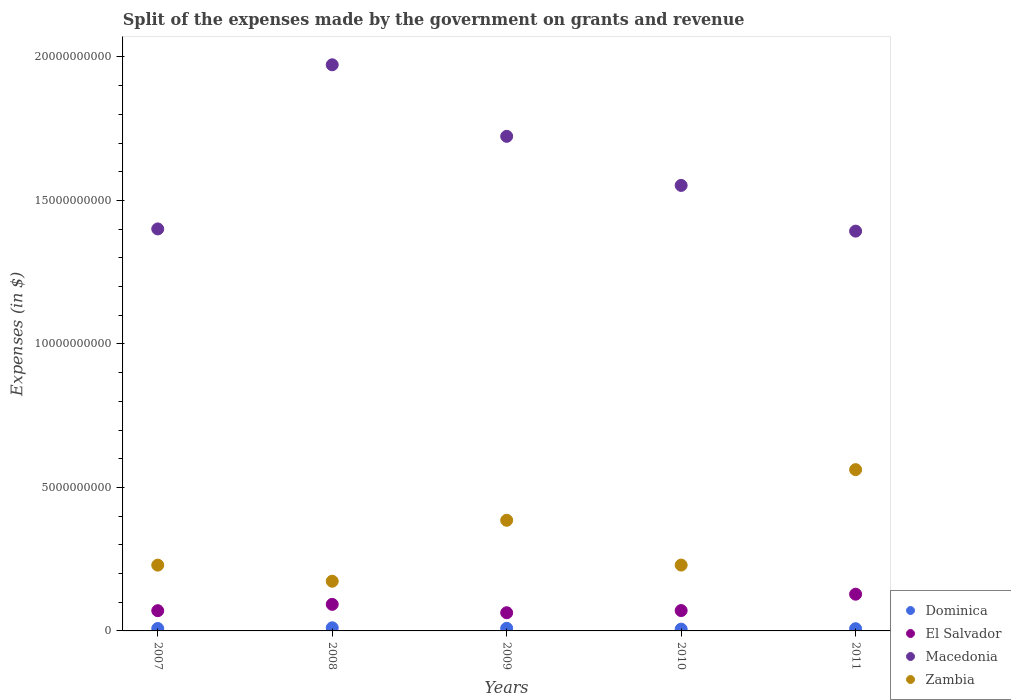Is the number of dotlines equal to the number of legend labels?
Your answer should be compact. Yes. What is the expenses made by the government on grants and revenue in Zambia in 2009?
Offer a very short reply. 3.86e+09. Across all years, what is the maximum expenses made by the government on grants and revenue in Zambia?
Offer a very short reply. 5.62e+09. Across all years, what is the minimum expenses made by the government on grants and revenue in El Salvador?
Keep it short and to the point. 6.34e+08. What is the total expenses made by the government on grants and revenue in Zambia in the graph?
Your answer should be compact. 1.58e+1. What is the difference between the expenses made by the government on grants and revenue in Macedonia in 2007 and that in 2008?
Make the answer very short. -5.72e+09. What is the difference between the expenses made by the government on grants and revenue in Zambia in 2011 and the expenses made by the government on grants and revenue in Macedonia in 2009?
Provide a succinct answer. -1.16e+1. What is the average expenses made by the government on grants and revenue in Dominica per year?
Offer a very short reply. 8.47e+07. In the year 2008, what is the difference between the expenses made by the government on grants and revenue in Dominica and expenses made by the government on grants and revenue in El Salvador?
Provide a succinct answer. -8.17e+08. What is the ratio of the expenses made by the government on grants and revenue in Dominica in 2008 to that in 2010?
Keep it short and to the point. 1.73. Is the expenses made by the government on grants and revenue in Macedonia in 2009 less than that in 2010?
Give a very brief answer. No. Is the difference between the expenses made by the government on grants and revenue in Dominica in 2008 and 2010 greater than the difference between the expenses made by the government on grants and revenue in El Salvador in 2008 and 2010?
Offer a very short reply. No. What is the difference between the highest and the second highest expenses made by the government on grants and revenue in El Salvador?
Your response must be concise. 3.54e+08. What is the difference between the highest and the lowest expenses made by the government on grants and revenue in Dominica?
Give a very brief answer. 4.58e+07. Is it the case that in every year, the sum of the expenses made by the government on grants and revenue in Zambia and expenses made by the government on grants and revenue in Dominica  is greater than the sum of expenses made by the government on grants and revenue in El Salvador and expenses made by the government on grants and revenue in Macedonia?
Your answer should be compact. Yes. Does the expenses made by the government on grants and revenue in Zambia monotonically increase over the years?
Your answer should be very brief. No. Is the expenses made by the government on grants and revenue in Macedonia strictly greater than the expenses made by the government on grants and revenue in Zambia over the years?
Provide a succinct answer. Yes. How many years are there in the graph?
Offer a terse response. 5. Are the values on the major ticks of Y-axis written in scientific E-notation?
Offer a terse response. No. Where does the legend appear in the graph?
Make the answer very short. Bottom right. How many legend labels are there?
Provide a succinct answer. 4. How are the legend labels stacked?
Offer a very short reply. Vertical. What is the title of the graph?
Ensure brevity in your answer.  Split of the expenses made by the government on grants and revenue. What is the label or title of the Y-axis?
Your answer should be very brief. Expenses (in $). What is the Expenses (in $) in Dominica in 2007?
Offer a very short reply. 8.40e+07. What is the Expenses (in $) of El Salvador in 2007?
Offer a terse response. 7.05e+08. What is the Expenses (in $) of Macedonia in 2007?
Ensure brevity in your answer.  1.40e+1. What is the Expenses (in $) of Zambia in 2007?
Your response must be concise. 2.29e+09. What is the Expenses (in $) of Dominica in 2008?
Ensure brevity in your answer.  1.09e+08. What is the Expenses (in $) in El Salvador in 2008?
Your answer should be very brief. 9.26e+08. What is the Expenses (in $) in Macedonia in 2008?
Offer a terse response. 1.97e+1. What is the Expenses (in $) in Zambia in 2008?
Offer a very short reply. 1.73e+09. What is the Expenses (in $) of Dominica in 2009?
Your answer should be very brief. 9.12e+07. What is the Expenses (in $) of El Salvador in 2009?
Ensure brevity in your answer.  6.34e+08. What is the Expenses (in $) in Macedonia in 2009?
Ensure brevity in your answer.  1.72e+1. What is the Expenses (in $) of Zambia in 2009?
Offer a terse response. 3.86e+09. What is the Expenses (in $) in Dominica in 2010?
Give a very brief answer. 6.28e+07. What is the Expenses (in $) of El Salvador in 2010?
Your response must be concise. 7.09e+08. What is the Expenses (in $) of Macedonia in 2010?
Your response must be concise. 1.55e+1. What is the Expenses (in $) in Zambia in 2010?
Keep it short and to the point. 2.29e+09. What is the Expenses (in $) of Dominica in 2011?
Give a very brief answer. 7.71e+07. What is the Expenses (in $) of El Salvador in 2011?
Your response must be concise. 1.28e+09. What is the Expenses (in $) in Macedonia in 2011?
Your answer should be very brief. 1.39e+1. What is the Expenses (in $) of Zambia in 2011?
Ensure brevity in your answer.  5.62e+09. Across all years, what is the maximum Expenses (in $) in Dominica?
Offer a terse response. 1.09e+08. Across all years, what is the maximum Expenses (in $) in El Salvador?
Make the answer very short. 1.28e+09. Across all years, what is the maximum Expenses (in $) of Macedonia?
Give a very brief answer. 1.97e+1. Across all years, what is the maximum Expenses (in $) of Zambia?
Your answer should be compact. 5.62e+09. Across all years, what is the minimum Expenses (in $) of Dominica?
Your response must be concise. 6.28e+07. Across all years, what is the minimum Expenses (in $) of El Salvador?
Provide a succinct answer. 6.34e+08. Across all years, what is the minimum Expenses (in $) of Macedonia?
Your response must be concise. 1.39e+1. Across all years, what is the minimum Expenses (in $) in Zambia?
Your answer should be compact. 1.73e+09. What is the total Expenses (in $) in Dominica in the graph?
Your answer should be very brief. 4.24e+08. What is the total Expenses (in $) of El Salvador in the graph?
Offer a very short reply. 4.25e+09. What is the total Expenses (in $) in Macedonia in the graph?
Your response must be concise. 8.04e+1. What is the total Expenses (in $) of Zambia in the graph?
Give a very brief answer. 1.58e+1. What is the difference between the Expenses (in $) in Dominica in 2007 and that in 2008?
Your response must be concise. -2.46e+07. What is the difference between the Expenses (in $) of El Salvador in 2007 and that in 2008?
Provide a short and direct response. -2.20e+08. What is the difference between the Expenses (in $) of Macedonia in 2007 and that in 2008?
Provide a succinct answer. -5.72e+09. What is the difference between the Expenses (in $) in Zambia in 2007 and that in 2008?
Your answer should be very brief. 5.61e+08. What is the difference between the Expenses (in $) of Dominica in 2007 and that in 2009?
Ensure brevity in your answer.  -7.20e+06. What is the difference between the Expenses (in $) in El Salvador in 2007 and that in 2009?
Keep it short and to the point. 7.15e+07. What is the difference between the Expenses (in $) of Macedonia in 2007 and that in 2009?
Offer a very short reply. -3.23e+09. What is the difference between the Expenses (in $) of Zambia in 2007 and that in 2009?
Your answer should be very brief. -1.56e+09. What is the difference between the Expenses (in $) of Dominica in 2007 and that in 2010?
Keep it short and to the point. 2.12e+07. What is the difference between the Expenses (in $) of El Salvador in 2007 and that in 2010?
Provide a short and direct response. -4.20e+06. What is the difference between the Expenses (in $) of Macedonia in 2007 and that in 2010?
Offer a very short reply. -1.52e+09. What is the difference between the Expenses (in $) in Zambia in 2007 and that in 2010?
Your response must be concise. -1.88e+06. What is the difference between the Expenses (in $) in Dominica in 2007 and that in 2011?
Keep it short and to the point. 6.90e+06. What is the difference between the Expenses (in $) in El Salvador in 2007 and that in 2011?
Ensure brevity in your answer.  -5.74e+08. What is the difference between the Expenses (in $) of Macedonia in 2007 and that in 2011?
Make the answer very short. 7.66e+07. What is the difference between the Expenses (in $) of Zambia in 2007 and that in 2011?
Provide a short and direct response. -3.33e+09. What is the difference between the Expenses (in $) of Dominica in 2008 and that in 2009?
Your response must be concise. 1.74e+07. What is the difference between the Expenses (in $) in El Salvador in 2008 and that in 2009?
Keep it short and to the point. 2.92e+08. What is the difference between the Expenses (in $) in Macedonia in 2008 and that in 2009?
Give a very brief answer. 2.49e+09. What is the difference between the Expenses (in $) in Zambia in 2008 and that in 2009?
Ensure brevity in your answer.  -2.12e+09. What is the difference between the Expenses (in $) in Dominica in 2008 and that in 2010?
Offer a terse response. 4.58e+07. What is the difference between the Expenses (in $) in El Salvador in 2008 and that in 2010?
Your answer should be very brief. 2.16e+08. What is the difference between the Expenses (in $) in Macedonia in 2008 and that in 2010?
Provide a short and direct response. 4.20e+09. What is the difference between the Expenses (in $) in Zambia in 2008 and that in 2010?
Offer a terse response. -5.63e+08. What is the difference between the Expenses (in $) of Dominica in 2008 and that in 2011?
Keep it short and to the point. 3.15e+07. What is the difference between the Expenses (in $) in El Salvador in 2008 and that in 2011?
Your answer should be very brief. -3.54e+08. What is the difference between the Expenses (in $) in Macedonia in 2008 and that in 2011?
Provide a succinct answer. 5.80e+09. What is the difference between the Expenses (in $) in Zambia in 2008 and that in 2011?
Provide a succinct answer. -3.89e+09. What is the difference between the Expenses (in $) in Dominica in 2009 and that in 2010?
Provide a succinct answer. 2.84e+07. What is the difference between the Expenses (in $) in El Salvador in 2009 and that in 2010?
Make the answer very short. -7.57e+07. What is the difference between the Expenses (in $) of Macedonia in 2009 and that in 2010?
Provide a short and direct response. 1.71e+09. What is the difference between the Expenses (in $) of Zambia in 2009 and that in 2010?
Offer a terse response. 1.56e+09. What is the difference between the Expenses (in $) of Dominica in 2009 and that in 2011?
Keep it short and to the point. 1.41e+07. What is the difference between the Expenses (in $) of El Salvador in 2009 and that in 2011?
Offer a very short reply. -6.46e+08. What is the difference between the Expenses (in $) of Macedonia in 2009 and that in 2011?
Make the answer very short. 3.30e+09. What is the difference between the Expenses (in $) in Zambia in 2009 and that in 2011?
Make the answer very short. -1.76e+09. What is the difference between the Expenses (in $) of Dominica in 2010 and that in 2011?
Your answer should be very brief. -1.43e+07. What is the difference between the Expenses (in $) in El Salvador in 2010 and that in 2011?
Your answer should be very brief. -5.70e+08. What is the difference between the Expenses (in $) in Macedonia in 2010 and that in 2011?
Offer a terse response. 1.59e+09. What is the difference between the Expenses (in $) of Zambia in 2010 and that in 2011?
Make the answer very short. -3.33e+09. What is the difference between the Expenses (in $) of Dominica in 2007 and the Expenses (in $) of El Salvador in 2008?
Provide a succinct answer. -8.42e+08. What is the difference between the Expenses (in $) of Dominica in 2007 and the Expenses (in $) of Macedonia in 2008?
Offer a terse response. -1.96e+1. What is the difference between the Expenses (in $) of Dominica in 2007 and the Expenses (in $) of Zambia in 2008?
Your answer should be very brief. -1.65e+09. What is the difference between the Expenses (in $) of El Salvador in 2007 and the Expenses (in $) of Macedonia in 2008?
Provide a short and direct response. -1.90e+1. What is the difference between the Expenses (in $) in El Salvador in 2007 and the Expenses (in $) in Zambia in 2008?
Your response must be concise. -1.03e+09. What is the difference between the Expenses (in $) of Macedonia in 2007 and the Expenses (in $) of Zambia in 2008?
Ensure brevity in your answer.  1.23e+1. What is the difference between the Expenses (in $) of Dominica in 2007 and the Expenses (in $) of El Salvador in 2009?
Provide a succinct answer. -5.50e+08. What is the difference between the Expenses (in $) of Dominica in 2007 and the Expenses (in $) of Macedonia in 2009?
Your response must be concise. -1.72e+1. What is the difference between the Expenses (in $) in Dominica in 2007 and the Expenses (in $) in Zambia in 2009?
Ensure brevity in your answer.  -3.77e+09. What is the difference between the Expenses (in $) of El Salvador in 2007 and the Expenses (in $) of Macedonia in 2009?
Make the answer very short. -1.65e+1. What is the difference between the Expenses (in $) in El Salvador in 2007 and the Expenses (in $) in Zambia in 2009?
Make the answer very short. -3.15e+09. What is the difference between the Expenses (in $) in Macedonia in 2007 and the Expenses (in $) in Zambia in 2009?
Offer a very short reply. 1.02e+1. What is the difference between the Expenses (in $) in Dominica in 2007 and the Expenses (in $) in El Salvador in 2010?
Your response must be concise. -6.25e+08. What is the difference between the Expenses (in $) of Dominica in 2007 and the Expenses (in $) of Macedonia in 2010?
Give a very brief answer. -1.54e+1. What is the difference between the Expenses (in $) in Dominica in 2007 and the Expenses (in $) in Zambia in 2010?
Your response must be concise. -2.21e+09. What is the difference between the Expenses (in $) of El Salvador in 2007 and the Expenses (in $) of Macedonia in 2010?
Ensure brevity in your answer.  -1.48e+1. What is the difference between the Expenses (in $) in El Salvador in 2007 and the Expenses (in $) in Zambia in 2010?
Provide a short and direct response. -1.59e+09. What is the difference between the Expenses (in $) of Macedonia in 2007 and the Expenses (in $) of Zambia in 2010?
Provide a succinct answer. 1.17e+1. What is the difference between the Expenses (in $) of Dominica in 2007 and the Expenses (in $) of El Salvador in 2011?
Give a very brief answer. -1.20e+09. What is the difference between the Expenses (in $) in Dominica in 2007 and the Expenses (in $) in Macedonia in 2011?
Make the answer very short. -1.38e+1. What is the difference between the Expenses (in $) of Dominica in 2007 and the Expenses (in $) of Zambia in 2011?
Your response must be concise. -5.54e+09. What is the difference between the Expenses (in $) in El Salvador in 2007 and the Expenses (in $) in Macedonia in 2011?
Keep it short and to the point. -1.32e+1. What is the difference between the Expenses (in $) of El Salvador in 2007 and the Expenses (in $) of Zambia in 2011?
Your answer should be very brief. -4.91e+09. What is the difference between the Expenses (in $) in Macedonia in 2007 and the Expenses (in $) in Zambia in 2011?
Make the answer very short. 8.39e+09. What is the difference between the Expenses (in $) of Dominica in 2008 and the Expenses (in $) of El Salvador in 2009?
Provide a succinct answer. -5.25e+08. What is the difference between the Expenses (in $) of Dominica in 2008 and the Expenses (in $) of Macedonia in 2009?
Keep it short and to the point. -1.71e+1. What is the difference between the Expenses (in $) of Dominica in 2008 and the Expenses (in $) of Zambia in 2009?
Your answer should be very brief. -3.75e+09. What is the difference between the Expenses (in $) of El Salvador in 2008 and the Expenses (in $) of Macedonia in 2009?
Ensure brevity in your answer.  -1.63e+1. What is the difference between the Expenses (in $) of El Salvador in 2008 and the Expenses (in $) of Zambia in 2009?
Your response must be concise. -2.93e+09. What is the difference between the Expenses (in $) of Macedonia in 2008 and the Expenses (in $) of Zambia in 2009?
Offer a very short reply. 1.59e+1. What is the difference between the Expenses (in $) in Dominica in 2008 and the Expenses (in $) in El Salvador in 2010?
Make the answer very short. -6.01e+08. What is the difference between the Expenses (in $) of Dominica in 2008 and the Expenses (in $) of Macedonia in 2010?
Provide a short and direct response. -1.54e+1. What is the difference between the Expenses (in $) of Dominica in 2008 and the Expenses (in $) of Zambia in 2010?
Ensure brevity in your answer.  -2.19e+09. What is the difference between the Expenses (in $) of El Salvador in 2008 and the Expenses (in $) of Macedonia in 2010?
Offer a very short reply. -1.46e+1. What is the difference between the Expenses (in $) of El Salvador in 2008 and the Expenses (in $) of Zambia in 2010?
Your response must be concise. -1.37e+09. What is the difference between the Expenses (in $) in Macedonia in 2008 and the Expenses (in $) in Zambia in 2010?
Make the answer very short. 1.74e+1. What is the difference between the Expenses (in $) of Dominica in 2008 and the Expenses (in $) of El Salvador in 2011?
Offer a terse response. -1.17e+09. What is the difference between the Expenses (in $) in Dominica in 2008 and the Expenses (in $) in Macedonia in 2011?
Give a very brief answer. -1.38e+1. What is the difference between the Expenses (in $) of Dominica in 2008 and the Expenses (in $) of Zambia in 2011?
Ensure brevity in your answer.  -5.51e+09. What is the difference between the Expenses (in $) of El Salvador in 2008 and the Expenses (in $) of Macedonia in 2011?
Give a very brief answer. -1.30e+1. What is the difference between the Expenses (in $) in El Salvador in 2008 and the Expenses (in $) in Zambia in 2011?
Provide a succinct answer. -4.69e+09. What is the difference between the Expenses (in $) of Macedonia in 2008 and the Expenses (in $) of Zambia in 2011?
Your response must be concise. 1.41e+1. What is the difference between the Expenses (in $) of Dominica in 2009 and the Expenses (in $) of El Salvador in 2010?
Provide a succinct answer. -6.18e+08. What is the difference between the Expenses (in $) in Dominica in 2009 and the Expenses (in $) in Macedonia in 2010?
Your answer should be compact. -1.54e+1. What is the difference between the Expenses (in $) in Dominica in 2009 and the Expenses (in $) in Zambia in 2010?
Ensure brevity in your answer.  -2.20e+09. What is the difference between the Expenses (in $) in El Salvador in 2009 and the Expenses (in $) in Macedonia in 2010?
Give a very brief answer. -1.49e+1. What is the difference between the Expenses (in $) in El Salvador in 2009 and the Expenses (in $) in Zambia in 2010?
Offer a terse response. -1.66e+09. What is the difference between the Expenses (in $) in Macedonia in 2009 and the Expenses (in $) in Zambia in 2010?
Make the answer very short. 1.49e+1. What is the difference between the Expenses (in $) in Dominica in 2009 and the Expenses (in $) in El Salvador in 2011?
Provide a succinct answer. -1.19e+09. What is the difference between the Expenses (in $) of Dominica in 2009 and the Expenses (in $) of Macedonia in 2011?
Your answer should be very brief. -1.38e+1. What is the difference between the Expenses (in $) of Dominica in 2009 and the Expenses (in $) of Zambia in 2011?
Your answer should be very brief. -5.53e+09. What is the difference between the Expenses (in $) in El Salvador in 2009 and the Expenses (in $) in Macedonia in 2011?
Offer a terse response. -1.33e+1. What is the difference between the Expenses (in $) in El Salvador in 2009 and the Expenses (in $) in Zambia in 2011?
Offer a very short reply. -4.99e+09. What is the difference between the Expenses (in $) in Macedonia in 2009 and the Expenses (in $) in Zambia in 2011?
Your answer should be very brief. 1.16e+1. What is the difference between the Expenses (in $) in Dominica in 2010 and the Expenses (in $) in El Salvador in 2011?
Ensure brevity in your answer.  -1.22e+09. What is the difference between the Expenses (in $) of Dominica in 2010 and the Expenses (in $) of Macedonia in 2011?
Your answer should be very brief. -1.39e+1. What is the difference between the Expenses (in $) in Dominica in 2010 and the Expenses (in $) in Zambia in 2011?
Keep it short and to the point. -5.56e+09. What is the difference between the Expenses (in $) of El Salvador in 2010 and the Expenses (in $) of Macedonia in 2011?
Make the answer very short. -1.32e+1. What is the difference between the Expenses (in $) in El Salvador in 2010 and the Expenses (in $) in Zambia in 2011?
Make the answer very short. -4.91e+09. What is the difference between the Expenses (in $) in Macedonia in 2010 and the Expenses (in $) in Zambia in 2011?
Offer a terse response. 9.90e+09. What is the average Expenses (in $) in Dominica per year?
Keep it short and to the point. 8.47e+07. What is the average Expenses (in $) of El Salvador per year?
Keep it short and to the point. 8.51e+08. What is the average Expenses (in $) in Macedonia per year?
Provide a short and direct response. 1.61e+1. What is the average Expenses (in $) of Zambia per year?
Provide a succinct answer. 3.16e+09. In the year 2007, what is the difference between the Expenses (in $) in Dominica and Expenses (in $) in El Salvador?
Ensure brevity in your answer.  -6.21e+08. In the year 2007, what is the difference between the Expenses (in $) of Dominica and Expenses (in $) of Macedonia?
Keep it short and to the point. -1.39e+1. In the year 2007, what is the difference between the Expenses (in $) of Dominica and Expenses (in $) of Zambia?
Offer a terse response. -2.21e+09. In the year 2007, what is the difference between the Expenses (in $) of El Salvador and Expenses (in $) of Macedonia?
Ensure brevity in your answer.  -1.33e+1. In the year 2007, what is the difference between the Expenses (in $) of El Salvador and Expenses (in $) of Zambia?
Your answer should be compact. -1.59e+09. In the year 2007, what is the difference between the Expenses (in $) of Macedonia and Expenses (in $) of Zambia?
Ensure brevity in your answer.  1.17e+1. In the year 2008, what is the difference between the Expenses (in $) in Dominica and Expenses (in $) in El Salvador?
Provide a succinct answer. -8.17e+08. In the year 2008, what is the difference between the Expenses (in $) of Dominica and Expenses (in $) of Macedonia?
Offer a terse response. -1.96e+1. In the year 2008, what is the difference between the Expenses (in $) of Dominica and Expenses (in $) of Zambia?
Your response must be concise. -1.62e+09. In the year 2008, what is the difference between the Expenses (in $) of El Salvador and Expenses (in $) of Macedonia?
Provide a short and direct response. -1.88e+1. In the year 2008, what is the difference between the Expenses (in $) of El Salvador and Expenses (in $) of Zambia?
Offer a very short reply. -8.06e+08. In the year 2008, what is the difference between the Expenses (in $) of Macedonia and Expenses (in $) of Zambia?
Your answer should be compact. 1.80e+1. In the year 2009, what is the difference between the Expenses (in $) in Dominica and Expenses (in $) in El Salvador?
Make the answer very short. -5.42e+08. In the year 2009, what is the difference between the Expenses (in $) of Dominica and Expenses (in $) of Macedonia?
Your answer should be compact. -1.71e+1. In the year 2009, what is the difference between the Expenses (in $) of Dominica and Expenses (in $) of Zambia?
Your response must be concise. -3.76e+09. In the year 2009, what is the difference between the Expenses (in $) in El Salvador and Expenses (in $) in Macedonia?
Offer a terse response. -1.66e+1. In the year 2009, what is the difference between the Expenses (in $) in El Salvador and Expenses (in $) in Zambia?
Keep it short and to the point. -3.22e+09. In the year 2009, what is the difference between the Expenses (in $) in Macedonia and Expenses (in $) in Zambia?
Your answer should be very brief. 1.34e+1. In the year 2010, what is the difference between the Expenses (in $) in Dominica and Expenses (in $) in El Salvador?
Your answer should be very brief. -6.47e+08. In the year 2010, what is the difference between the Expenses (in $) in Dominica and Expenses (in $) in Macedonia?
Provide a succinct answer. -1.55e+1. In the year 2010, what is the difference between the Expenses (in $) in Dominica and Expenses (in $) in Zambia?
Your answer should be very brief. -2.23e+09. In the year 2010, what is the difference between the Expenses (in $) of El Salvador and Expenses (in $) of Macedonia?
Give a very brief answer. -1.48e+1. In the year 2010, what is the difference between the Expenses (in $) of El Salvador and Expenses (in $) of Zambia?
Your answer should be very brief. -1.59e+09. In the year 2010, what is the difference between the Expenses (in $) of Macedonia and Expenses (in $) of Zambia?
Give a very brief answer. 1.32e+1. In the year 2011, what is the difference between the Expenses (in $) in Dominica and Expenses (in $) in El Salvador?
Keep it short and to the point. -1.20e+09. In the year 2011, what is the difference between the Expenses (in $) in Dominica and Expenses (in $) in Macedonia?
Provide a short and direct response. -1.39e+1. In the year 2011, what is the difference between the Expenses (in $) in Dominica and Expenses (in $) in Zambia?
Give a very brief answer. -5.54e+09. In the year 2011, what is the difference between the Expenses (in $) in El Salvador and Expenses (in $) in Macedonia?
Provide a succinct answer. -1.27e+1. In the year 2011, what is the difference between the Expenses (in $) in El Salvador and Expenses (in $) in Zambia?
Make the answer very short. -4.34e+09. In the year 2011, what is the difference between the Expenses (in $) in Macedonia and Expenses (in $) in Zambia?
Offer a terse response. 8.31e+09. What is the ratio of the Expenses (in $) of Dominica in 2007 to that in 2008?
Ensure brevity in your answer.  0.77. What is the ratio of the Expenses (in $) of El Salvador in 2007 to that in 2008?
Offer a terse response. 0.76. What is the ratio of the Expenses (in $) of Macedonia in 2007 to that in 2008?
Provide a succinct answer. 0.71. What is the ratio of the Expenses (in $) in Zambia in 2007 to that in 2008?
Keep it short and to the point. 1.32. What is the ratio of the Expenses (in $) of Dominica in 2007 to that in 2009?
Offer a terse response. 0.92. What is the ratio of the Expenses (in $) in El Salvador in 2007 to that in 2009?
Your response must be concise. 1.11. What is the ratio of the Expenses (in $) in Macedonia in 2007 to that in 2009?
Ensure brevity in your answer.  0.81. What is the ratio of the Expenses (in $) of Zambia in 2007 to that in 2009?
Provide a short and direct response. 0.59. What is the ratio of the Expenses (in $) in Dominica in 2007 to that in 2010?
Offer a very short reply. 1.34. What is the ratio of the Expenses (in $) of El Salvador in 2007 to that in 2010?
Your response must be concise. 0.99. What is the ratio of the Expenses (in $) in Macedonia in 2007 to that in 2010?
Offer a terse response. 0.9. What is the ratio of the Expenses (in $) of Dominica in 2007 to that in 2011?
Provide a succinct answer. 1.09. What is the ratio of the Expenses (in $) of El Salvador in 2007 to that in 2011?
Your response must be concise. 0.55. What is the ratio of the Expenses (in $) of Macedonia in 2007 to that in 2011?
Keep it short and to the point. 1.01. What is the ratio of the Expenses (in $) in Zambia in 2007 to that in 2011?
Offer a terse response. 0.41. What is the ratio of the Expenses (in $) of Dominica in 2008 to that in 2009?
Offer a very short reply. 1.19. What is the ratio of the Expenses (in $) in El Salvador in 2008 to that in 2009?
Your answer should be very brief. 1.46. What is the ratio of the Expenses (in $) of Macedonia in 2008 to that in 2009?
Provide a succinct answer. 1.14. What is the ratio of the Expenses (in $) of Zambia in 2008 to that in 2009?
Ensure brevity in your answer.  0.45. What is the ratio of the Expenses (in $) of Dominica in 2008 to that in 2010?
Your answer should be compact. 1.73. What is the ratio of the Expenses (in $) of El Salvador in 2008 to that in 2010?
Keep it short and to the point. 1.3. What is the ratio of the Expenses (in $) of Macedonia in 2008 to that in 2010?
Ensure brevity in your answer.  1.27. What is the ratio of the Expenses (in $) in Zambia in 2008 to that in 2010?
Provide a short and direct response. 0.75. What is the ratio of the Expenses (in $) in Dominica in 2008 to that in 2011?
Ensure brevity in your answer.  1.41. What is the ratio of the Expenses (in $) in El Salvador in 2008 to that in 2011?
Keep it short and to the point. 0.72. What is the ratio of the Expenses (in $) in Macedonia in 2008 to that in 2011?
Offer a very short reply. 1.42. What is the ratio of the Expenses (in $) of Zambia in 2008 to that in 2011?
Offer a very short reply. 0.31. What is the ratio of the Expenses (in $) in Dominica in 2009 to that in 2010?
Ensure brevity in your answer.  1.45. What is the ratio of the Expenses (in $) in El Salvador in 2009 to that in 2010?
Offer a terse response. 0.89. What is the ratio of the Expenses (in $) in Macedonia in 2009 to that in 2010?
Offer a terse response. 1.11. What is the ratio of the Expenses (in $) in Zambia in 2009 to that in 2010?
Provide a short and direct response. 1.68. What is the ratio of the Expenses (in $) in Dominica in 2009 to that in 2011?
Provide a short and direct response. 1.18. What is the ratio of the Expenses (in $) of El Salvador in 2009 to that in 2011?
Make the answer very short. 0.5. What is the ratio of the Expenses (in $) in Macedonia in 2009 to that in 2011?
Ensure brevity in your answer.  1.24. What is the ratio of the Expenses (in $) of Zambia in 2009 to that in 2011?
Your answer should be compact. 0.69. What is the ratio of the Expenses (in $) of Dominica in 2010 to that in 2011?
Your response must be concise. 0.81. What is the ratio of the Expenses (in $) in El Salvador in 2010 to that in 2011?
Offer a terse response. 0.55. What is the ratio of the Expenses (in $) of Macedonia in 2010 to that in 2011?
Keep it short and to the point. 1.11. What is the ratio of the Expenses (in $) in Zambia in 2010 to that in 2011?
Your answer should be compact. 0.41. What is the difference between the highest and the second highest Expenses (in $) of Dominica?
Offer a very short reply. 1.74e+07. What is the difference between the highest and the second highest Expenses (in $) in El Salvador?
Offer a very short reply. 3.54e+08. What is the difference between the highest and the second highest Expenses (in $) in Macedonia?
Offer a very short reply. 2.49e+09. What is the difference between the highest and the second highest Expenses (in $) in Zambia?
Your response must be concise. 1.76e+09. What is the difference between the highest and the lowest Expenses (in $) of Dominica?
Give a very brief answer. 4.58e+07. What is the difference between the highest and the lowest Expenses (in $) of El Salvador?
Offer a terse response. 6.46e+08. What is the difference between the highest and the lowest Expenses (in $) in Macedonia?
Provide a short and direct response. 5.80e+09. What is the difference between the highest and the lowest Expenses (in $) in Zambia?
Your answer should be compact. 3.89e+09. 